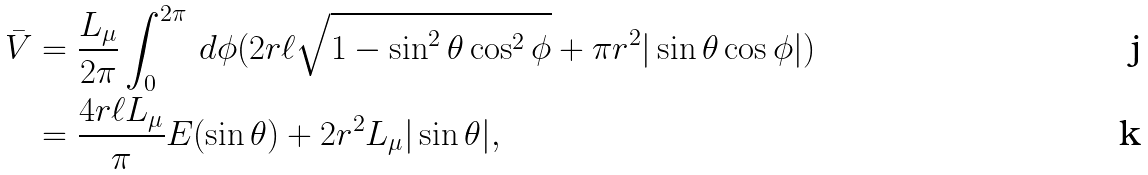Convert formula to latex. <formula><loc_0><loc_0><loc_500><loc_500>\bar { V } & = \frac { L _ { \mu } } { 2 \pi } \int _ { 0 } ^ { 2 \pi } \, d \phi ( 2 r \ell \sqrt { 1 - \sin ^ { 2 } \theta \cos ^ { 2 } \phi } + \pi r ^ { 2 } | \sin \theta \cos \phi | ) \\ & = \frac { 4 r \ell L _ { \mu } } { \pi } E ( \sin \theta ) + 2 r ^ { 2 } L _ { \mu } | \sin \theta | ,</formula> 